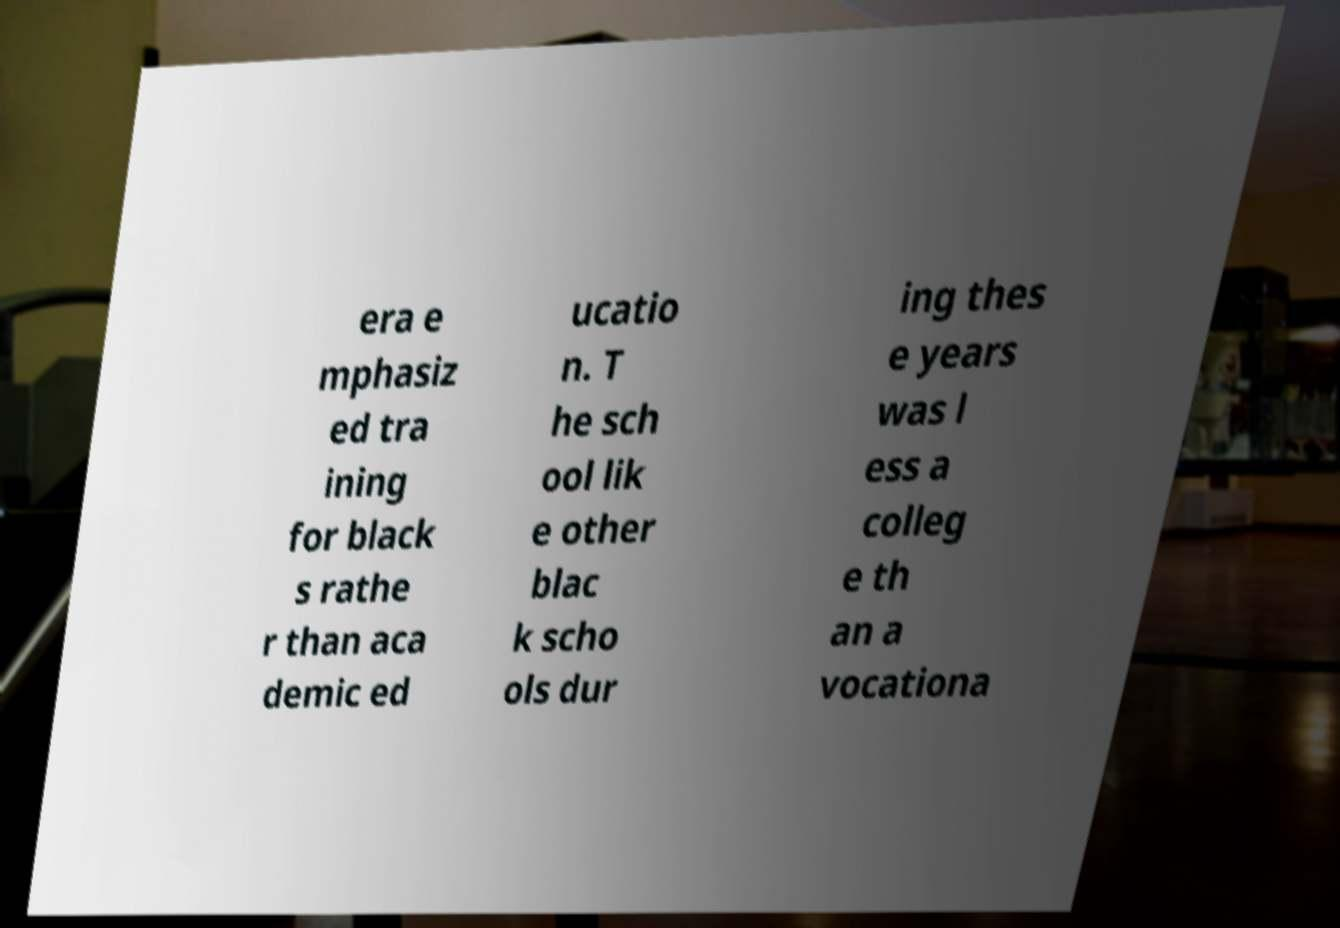Please read and relay the text visible in this image. What does it say? era e mphasiz ed tra ining for black s rathe r than aca demic ed ucatio n. T he sch ool lik e other blac k scho ols dur ing thes e years was l ess a colleg e th an a vocationa 